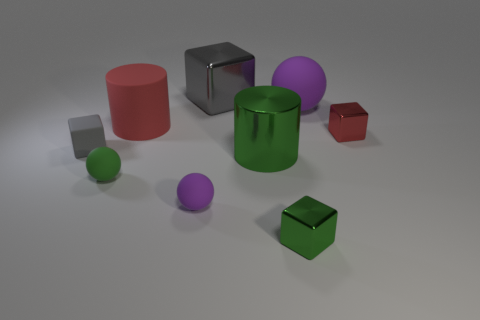How many objects are either red things left of the tiny green cube or small green rubber objects?
Keep it short and to the point. 2. There is a large rubber cylinder; is it the same color as the tiny shiny cube that is in front of the gray rubber thing?
Keep it short and to the point. No. Are there any other things that have the same size as the red rubber thing?
Ensure brevity in your answer.  Yes. There is a red object left of the big shiny cylinder that is right of the big gray cube; what size is it?
Your answer should be very brief. Large. What number of objects are tiny green rubber objects or purple balls that are on the right side of the green cylinder?
Give a very brief answer. 2. Is the shape of the purple matte thing that is behind the large green shiny object the same as  the tiny purple object?
Keep it short and to the point. Yes. There is a metal object right of the purple matte thing to the right of the large gray shiny block; what number of tiny gray matte blocks are behind it?
Offer a terse response. 0. Are there any other things that have the same shape as the gray rubber object?
Your answer should be very brief. Yes. How many things are either green spheres or purple matte balls?
Your answer should be very brief. 3. Do the big green thing and the purple object to the left of the green cylinder have the same shape?
Your response must be concise. No. 